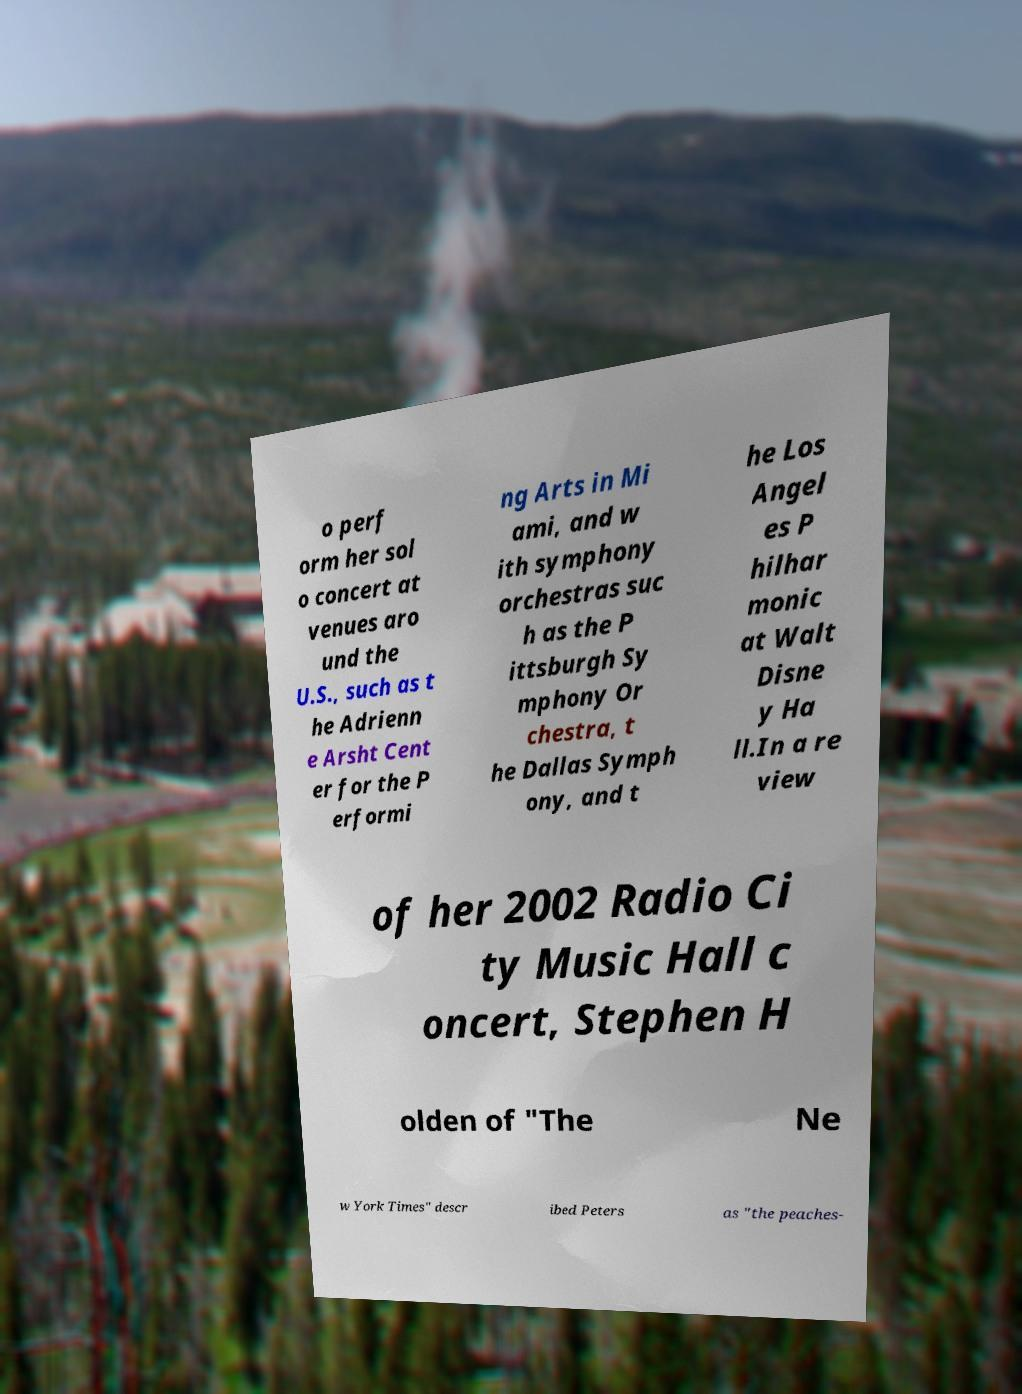Can you accurately transcribe the text from the provided image for me? o perf orm her sol o concert at venues aro und the U.S., such as t he Adrienn e Arsht Cent er for the P erformi ng Arts in Mi ami, and w ith symphony orchestras suc h as the P ittsburgh Sy mphony Or chestra, t he Dallas Symph ony, and t he Los Angel es P hilhar monic at Walt Disne y Ha ll.In a re view of her 2002 Radio Ci ty Music Hall c oncert, Stephen H olden of "The Ne w York Times" descr ibed Peters as "the peaches- 